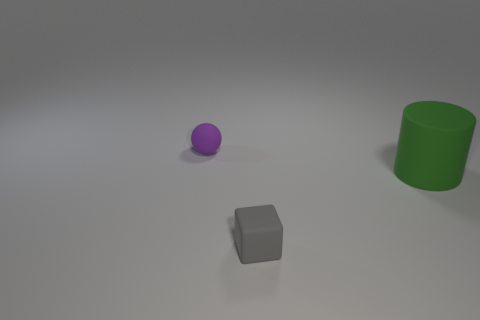How many objects are either rubber objects that are in front of the tiny purple object or things that are in front of the big matte cylinder?
Your response must be concise. 2. Is there another tiny gray thing of the same shape as the tiny gray object?
Your answer should be very brief. No. How many metal things are either small cubes or purple things?
Offer a very short reply. 0. There is a purple matte thing; what shape is it?
Your answer should be compact. Sphere. How many objects are the same material as the small purple ball?
Keep it short and to the point. 2. There is a tiny cube that is made of the same material as the tiny purple object; what color is it?
Give a very brief answer. Gray. There is a purple matte object that is left of the gray cube; is its size the same as the green thing?
Ensure brevity in your answer.  No. There is a small rubber thing that is in front of the small object on the left side of the gray cube that is in front of the large green cylinder; what is its shape?
Offer a terse response. Cube. Is the shape of the purple thing the same as the gray rubber object?
Offer a very short reply. No. There is a rubber thing that is behind the large green rubber thing behind the small gray thing; what shape is it?
Keep it short and to the point. Sphere. 